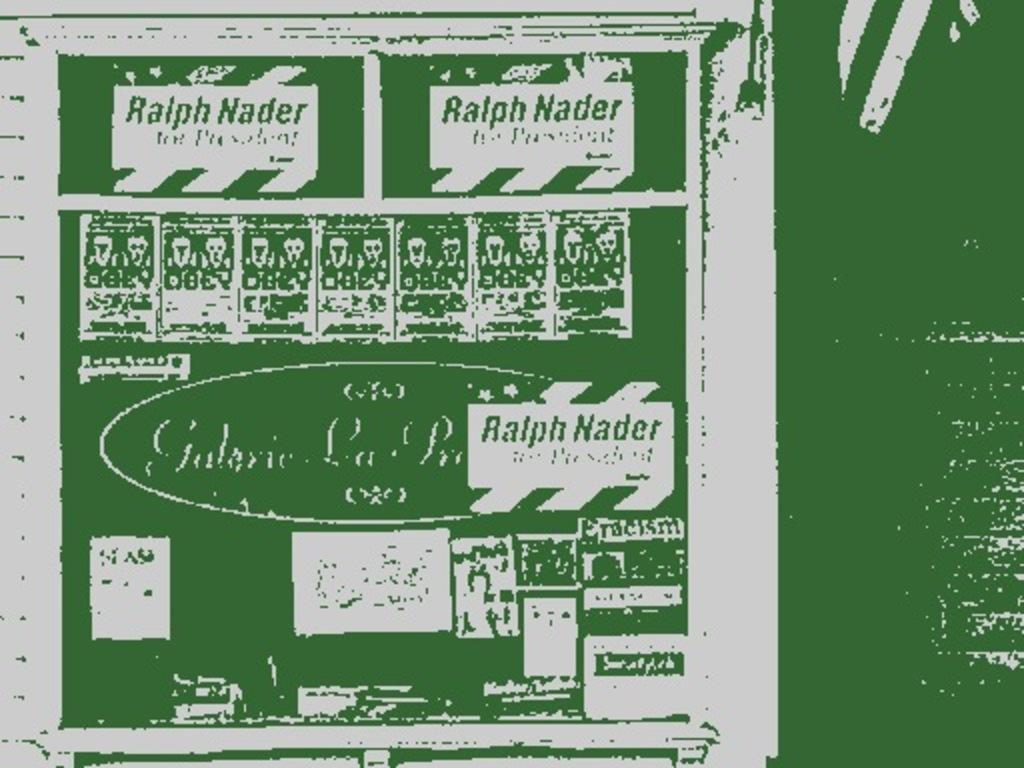Provide a one-sentence caption for the provided image. Piece of paper with the name Ralph Nader wrote all on it. 